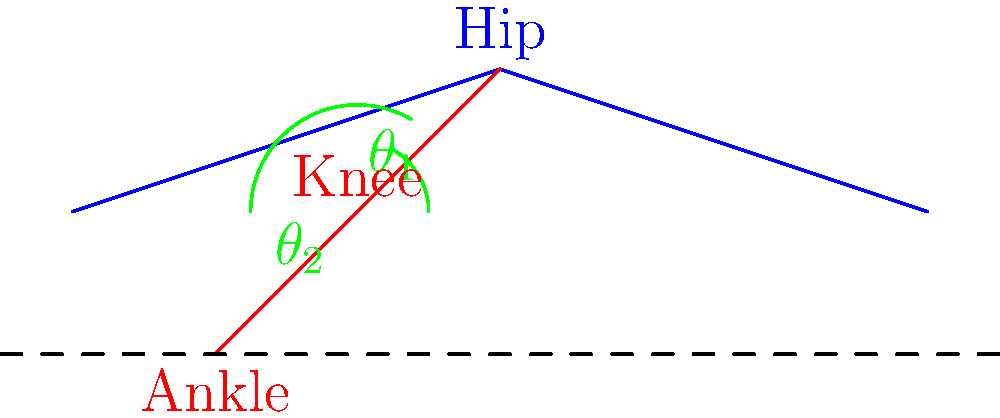In the diagram of a cat's hind leg during a leap, identify the joint angles $\theta_1$ and $\theta_2$. How do these angles typically change as the cat prepares to jump, and what is their biomechanical significance in generating power for the leap? To understand the biomechanics of a cat's leap, let's analyze the joint angles step-by-step:

1. Identification of angles:
   $\theta_1$: Hip joint angle (between the body and upper hind leg)
   $\theta_2$: Knee joint angle (between upper and lower hind leg)

2. Changes during preparation for jump:
   a. Initially, both $\theta_1$ and $\theta_2$ decrease as the cat crouches.
   b. $\theta_1$ may reach about 30-45 degrees.
   c. $\theta_2$ may decrease to about 45-60 degrees.

3. Biomechanical significance:
   a. Decreased angles allow for greater muscle stretch, utilizing the stretch-shortening cycle.
   b. This positioning increases the range of motion for the jump.
   c. It allows for greater force production during the concentric phase of the jump.

4. Power generation:
   a. As the cat initiates the jump, both $\theta_1$ and $\theta_2$ rapidly increase.
   b. This extension of hip and knee joints generates power for the leap.
   c. The rapid increase in angles results in high angular velocities, contributing to the power output.

5. Energy transfer:
   a. The sequential extension of joints (hip, then knee, then ankle) allows for optimal energy transfer.
   b. This sequence maximizes the power output and jump height.

Understanding these angle changes helps illustrators accurately depict the dynamic postures of cats during various stages of a leap, enhancing the realism of animal drawings.
Answer: $\theta_1$ and $\theta_2$ decrease during crouch, then rapidly increase during jump, optimizing muscle stretch and power generation. 